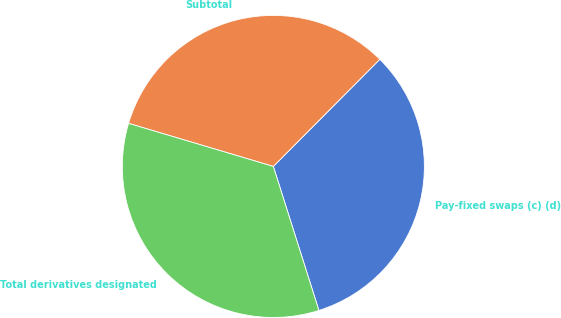Convert chart to OTSL. <chart><loc_0><loc_0><loc_500><loc_500><pie_chart><fcel>Pay-fixed swaps (c) (d)<fcel>Subtotal<fcel>Total derivatives designated<nl><fcel>32.67%<fcel>32.85%<fcel>34.48%<nl></chart> 